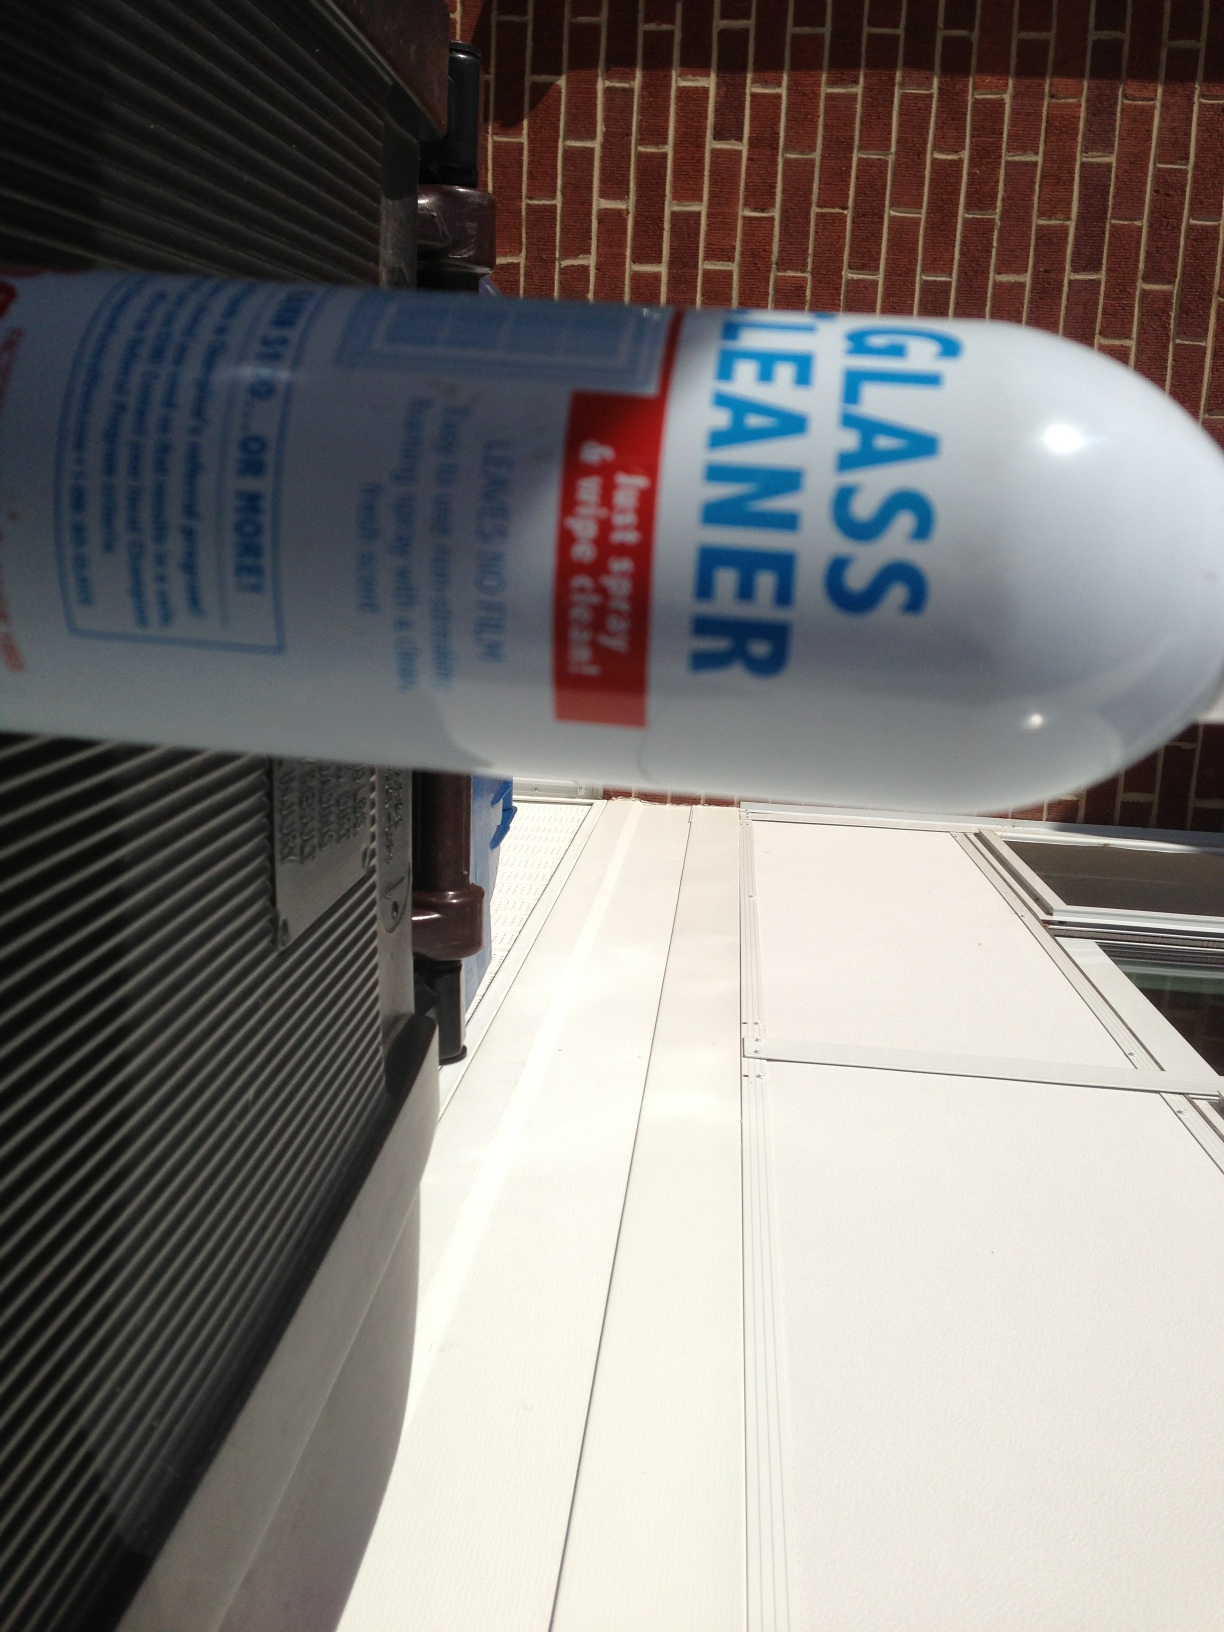What is in this can? from Vizwiz glass cleaner 